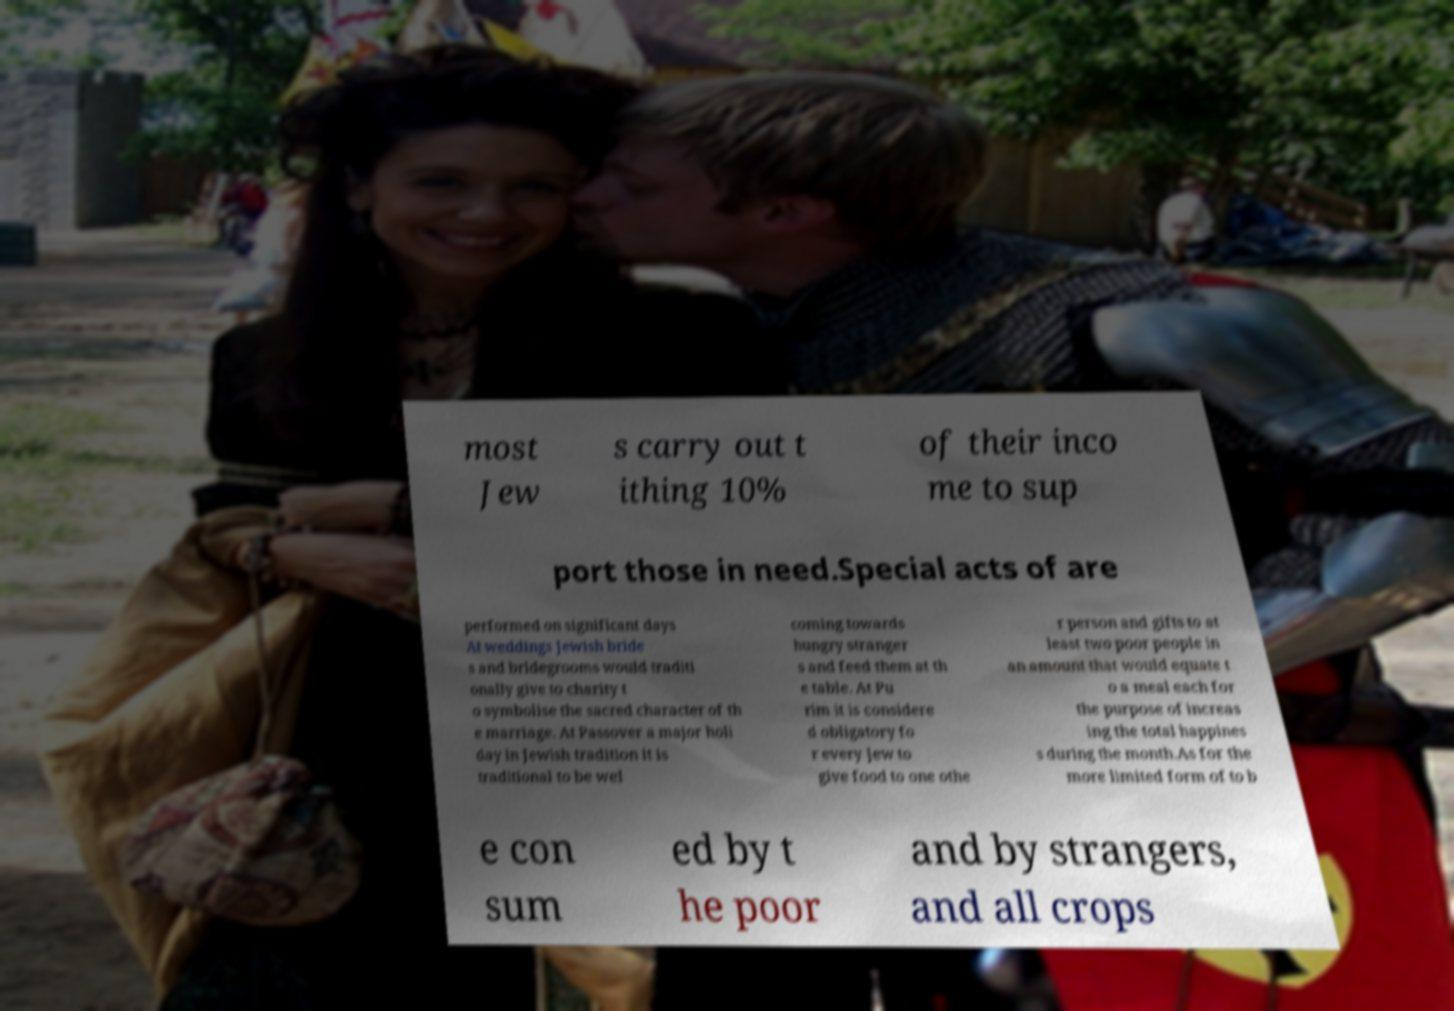Can you accurately transcribe the text from the provided image for me? most Jew s carry out t ithing 10% of their inco me to sup port those in need.Special acts of are performed on significant days At weddings Jewish bride s and bridegrooms would traditi onally give to charity t o symbolise the sacred character of th e marriage. At Passover a major holi day in Jewish tradition it is traditional to be wel coming towards hungry stranger s and feed them at th e table. At Pu rim it is considere d obligatory fo r every Jew to give food to one othe r person and gifts to at least two poor people in an amount that would equate t o a meal each for the purpose of increas ing the total happines s during the month.As for the more limited form of to b e con sum ed by t he poor and by strangers, and all crops 